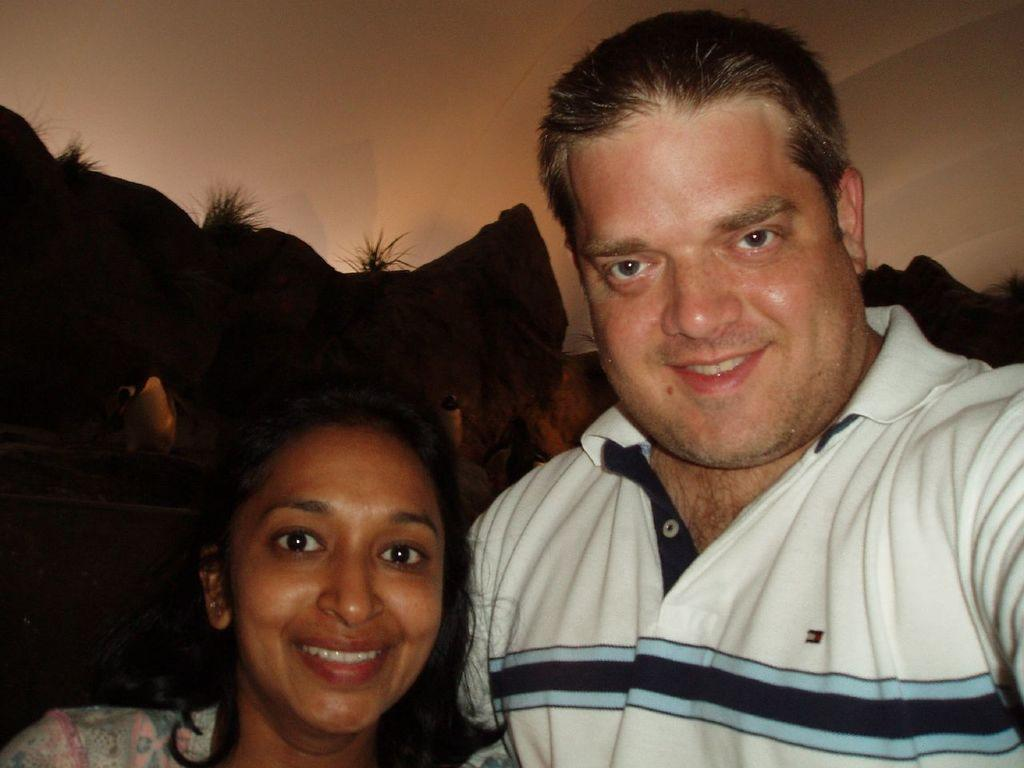Who is present in the image? There is a man and a woman in the image. What expressions do the man and woman have? Both the man and the woman are smiling in the image. What can be seen in the image besides the man and woman? There are objects visible in the image. What is visible in the background of the image? There is a wall in the background of the image. What type of dolls are being ordered by the man in the image? There are no dolls present in the image, and the man is not ordering anything. 